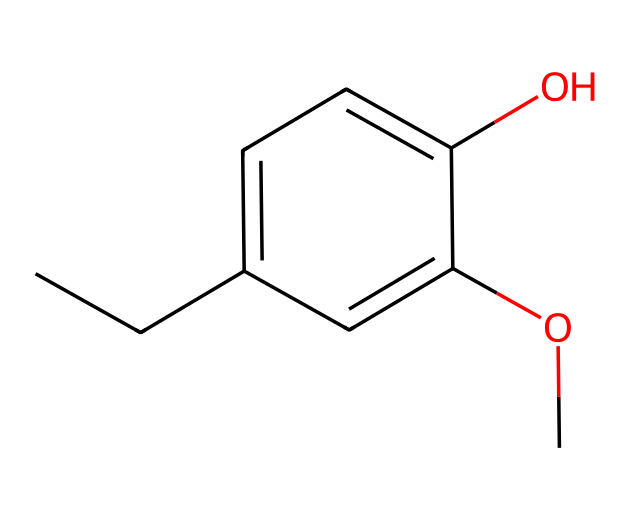What is the molecular formula of eugenol? By analyzing the SMILES representation, we can count the types and number of atoms present. The structure contains 10 carbon (C) atoms, 12 hydrogen (H) atoms, and 2 oxygen (O) atoms, leading us to the molecular formula C10H12O2.
Answer: C10H12O2 How many hydroxyl groups does eugenol contain? In the structure represented by the SMILES, the "O" in "O" indicates the presence of a hydroxyl (-OH) group. There is one such group in the structure, which is attached to a carbon in the benzene ring.
Answer: 1 Is eugenol a saturated or unsaturated compound? Looking at the structure, the presence of double bonds in the ring and between carbon atoms indicates that eugenol is unsaturated. An unsaturated compound has at least one double bond in its structure.
Answer: unsaturated Which functional group is present in eugenol that contributes to its aromatic properties? The presence of the benzene ring indicates that eugenol has aromatic properties. Aromatic compounds typically contain a cyclic structure with alternating double bonds, contributing to their distinct fragrance.
Answer: aromatic ring What type of scent is associated with eugenol? Eugenol is known for its clove-like scent, which is characteristic of the compounds derived from clove oil. This association is evident through both sensory perceptions and its traditional use in perfumery.
Answer: clove-like Does eugenol have any antioxidant properties? Eugenol is known for its antioxidant properties, which can be attributed to the presence of the hydroxyl group, allowing it to donate hydrogen atoms to free radicals, thus stabilizing them.
Answer: yes 